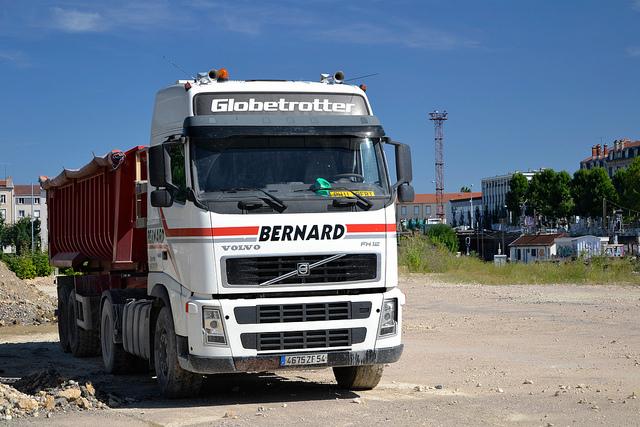Who is the maker of this truck?
Give a very brief answer. Bernard. What is the name on the truck that sounds like a famous basketball team?
Concise answer only. Globetrotter. What is written on the windshield?
Quick response, please. Globetrotter. What color is the truck's bed?
Write a very short answer. Red. Is this a semi truck?
Give a very brief answer. Yes. How many trucks are there?
Write a very short answer. 1. 